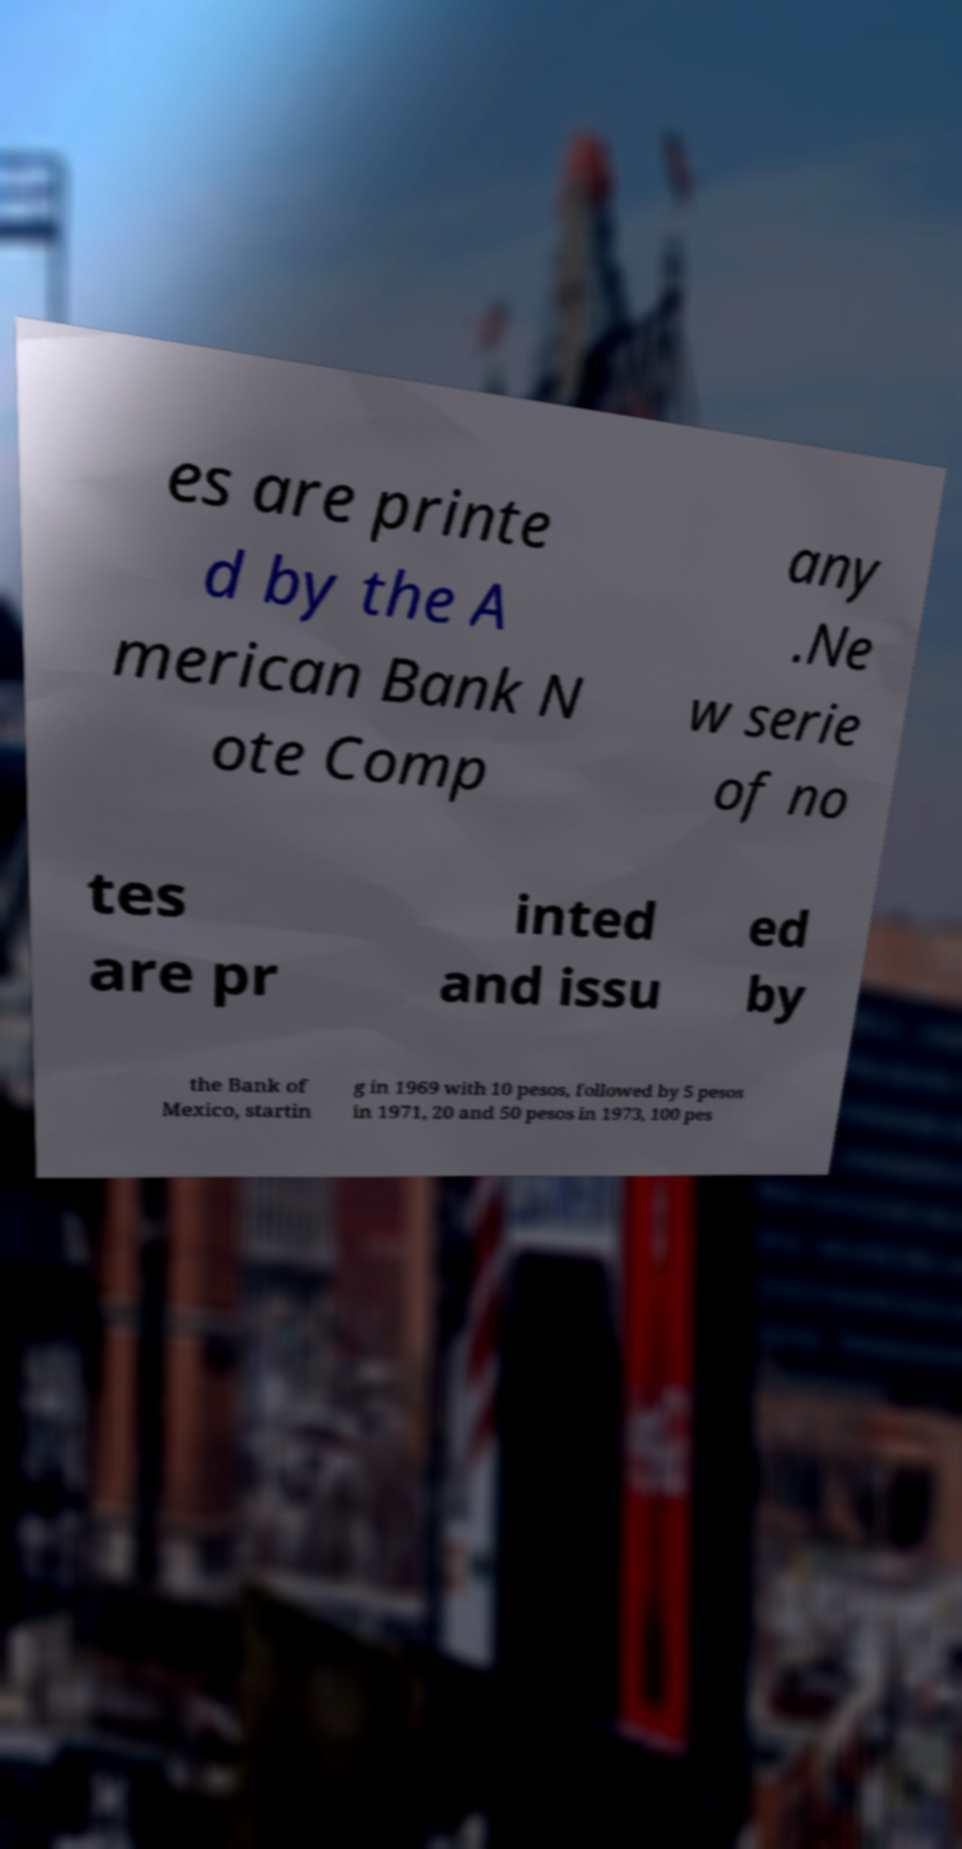For documentation purposes, I need the text within this image transcribed. Could you provide that? es are printe d by the A merican Bank N ote Comp any .Ne w serie of no tes are pr inted and issu ed by the Bank of Mexico, startin g in 1969 with 10 pesos, followed by 5 pesos in 1971, 20 and 50 pesos in 1973, 100 pes 